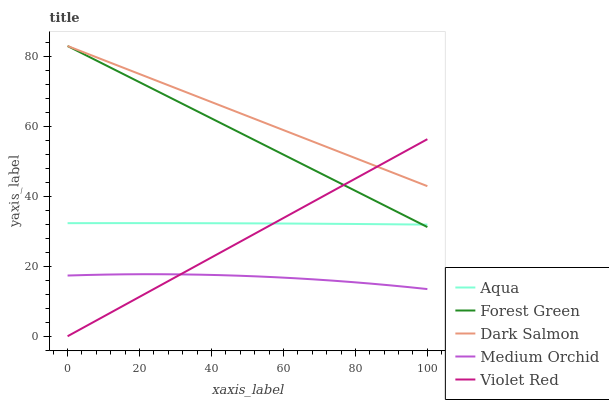Does Medium Orchid have the minimum area under the curve?
Answer yes or no. Yes. Does Dark Salmon have the maximum area under the curve?
Answer yes or no. Yes. Does Forest Green have the minimum area under the curve?
Answer yes or no. No. Does Forest Green have the maximum area under the curve?
Answer yes or no. No. Is Violet Red the smoothest?
Answer yes or no. Yes. Is Medium Orchid the roughest?
Answer yes or no. Yes. Is Forest Green the smoothest?
Answer yes or no. No. Is Forest Green the roughest?
Answer yes or no. No. Does Violet Red have the lowest value?
Answer yes or no. Yes. Does Forest Green have the lowest value?
Answer yes or no. No. Does Dark Salmon have the highest value?
Answer yes or no. Yes. Does Medium Orchid have the highest value?
Answer yes or no. No. Is Medium Orchid less than Dark Salmon?
Answer yes or no. Yes. Is Aqua greater than Medium Orchid?
Answer yes or no. Yes. Does Violet Red intersect Forest Green?
Answer yes or no. Yes. Is Violet Red less than Forest Green?
Answer yes or no. No. Is Violet Red greater than Forest Green?
Answer yes or no. No. Does Medium Orchid intersect Dark Salmon?
Answer yes or no. No. 